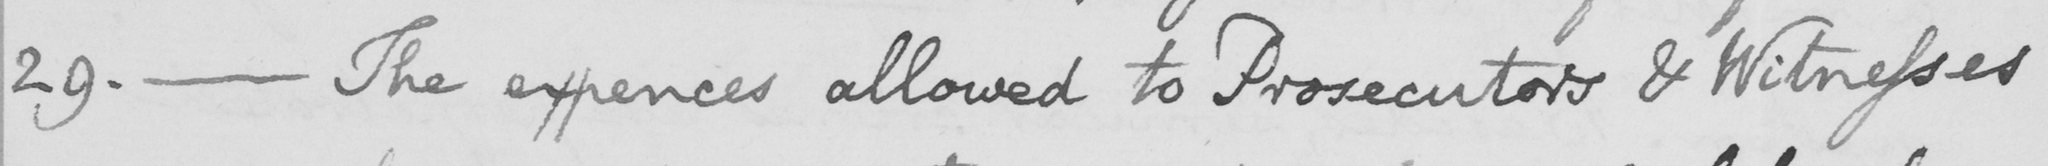What does this handwritten line say? 29. _ The Expences allowed to Prosecutors & Witnesses 